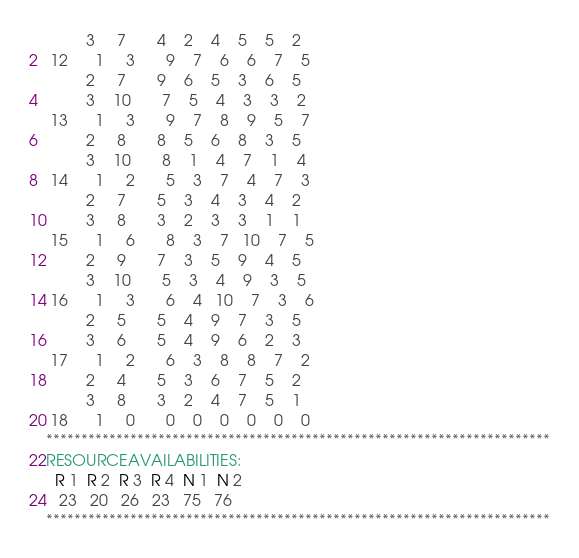Convert code to text. <code><loc_0><loc_0><loc_500><loc_500><_ObjectiveC_>         3     7       4    2    4    5    5    2
 12      1     3       9    7    6    6    7    5
         2     7       9    6    5    3    6    5
         3    10       7    5    4    3    3    2
 13      1     3       9    7    8    9    5    7
         2     8       8    5    6    8    3    5
         3    10       8    1    4    7    1    4
 14      1     2       5    3    7    4    7    3
         2     7       5    3    4    3    4    2
         3     8       3    2    3    3    1    1
 15      1     6       8    3    7   10    7    5
         2     9       7    3    5    9    4    5
         3    10       5    3    4    9    3    5
 16      1     3       6    4   10    7    3    6
         2     5       5    4    9    7    3    5
         3     6       5    4    9    6    2    3
 17      1     2       6    3    8    8    7    2
         2     4       5    3    6    7    5    2
         3     8       3    2    4    7    5    1
 18      1     0       0    0    0    0    0    0
************************************************************************
RESOURCEAVAILABILITIES:
  R 1  R 2  R 3  R 4  N 1  N 2
   23   20   26   23   75   76
************************************************************************
</code> 